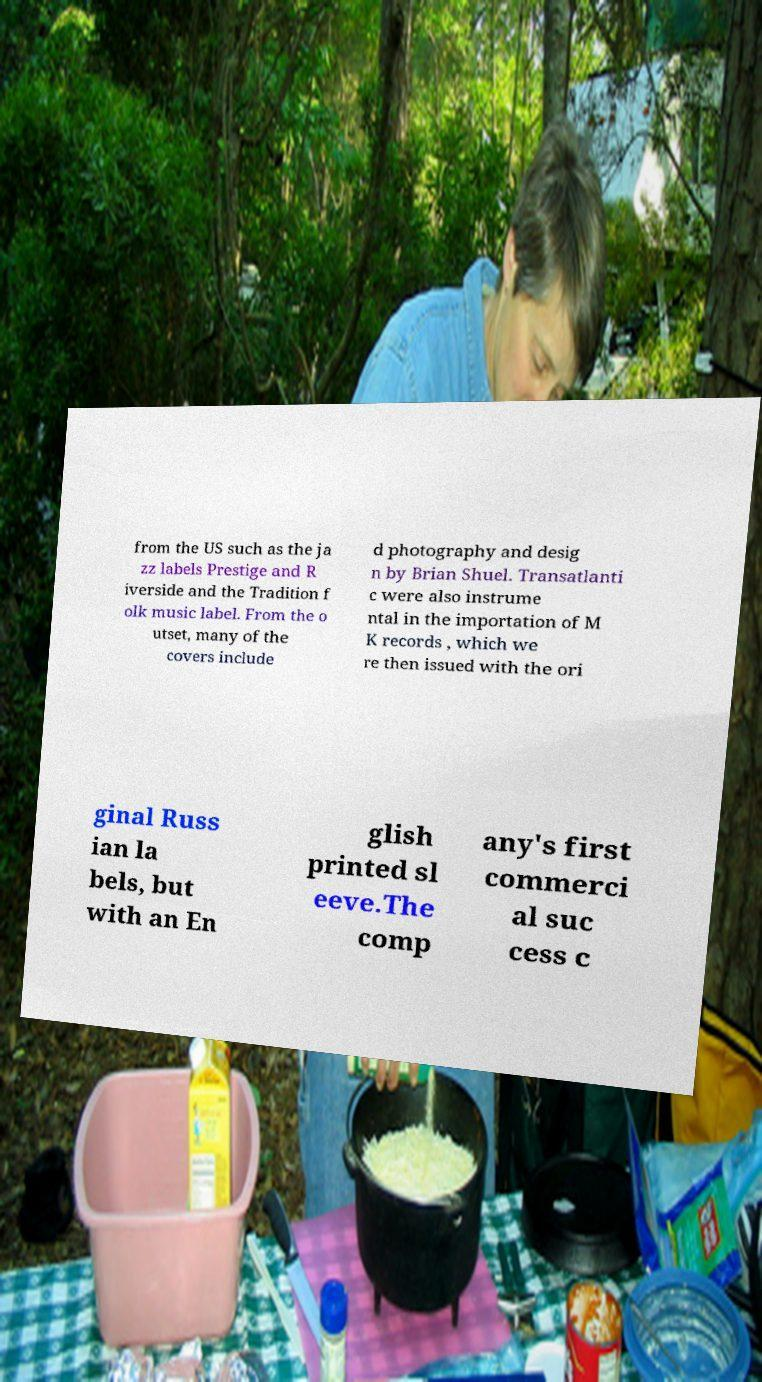Can you read and provide the text displayed in the image?This photo seems to have some interesting text. Can you extract and type it out for me? from the US such as the ja zz labels Prestige and R iverside and the Tradition f olk music label. From the o utset, many of the covers include d photography and desig n by Brian Shuel. Transatlanti c were also instrume ntal in the importation of M K records , which we re then issued with the ori ginal Russ ian la bels, but with an En glish printed sl eeve.The comp any's first commerci al suc cess c 